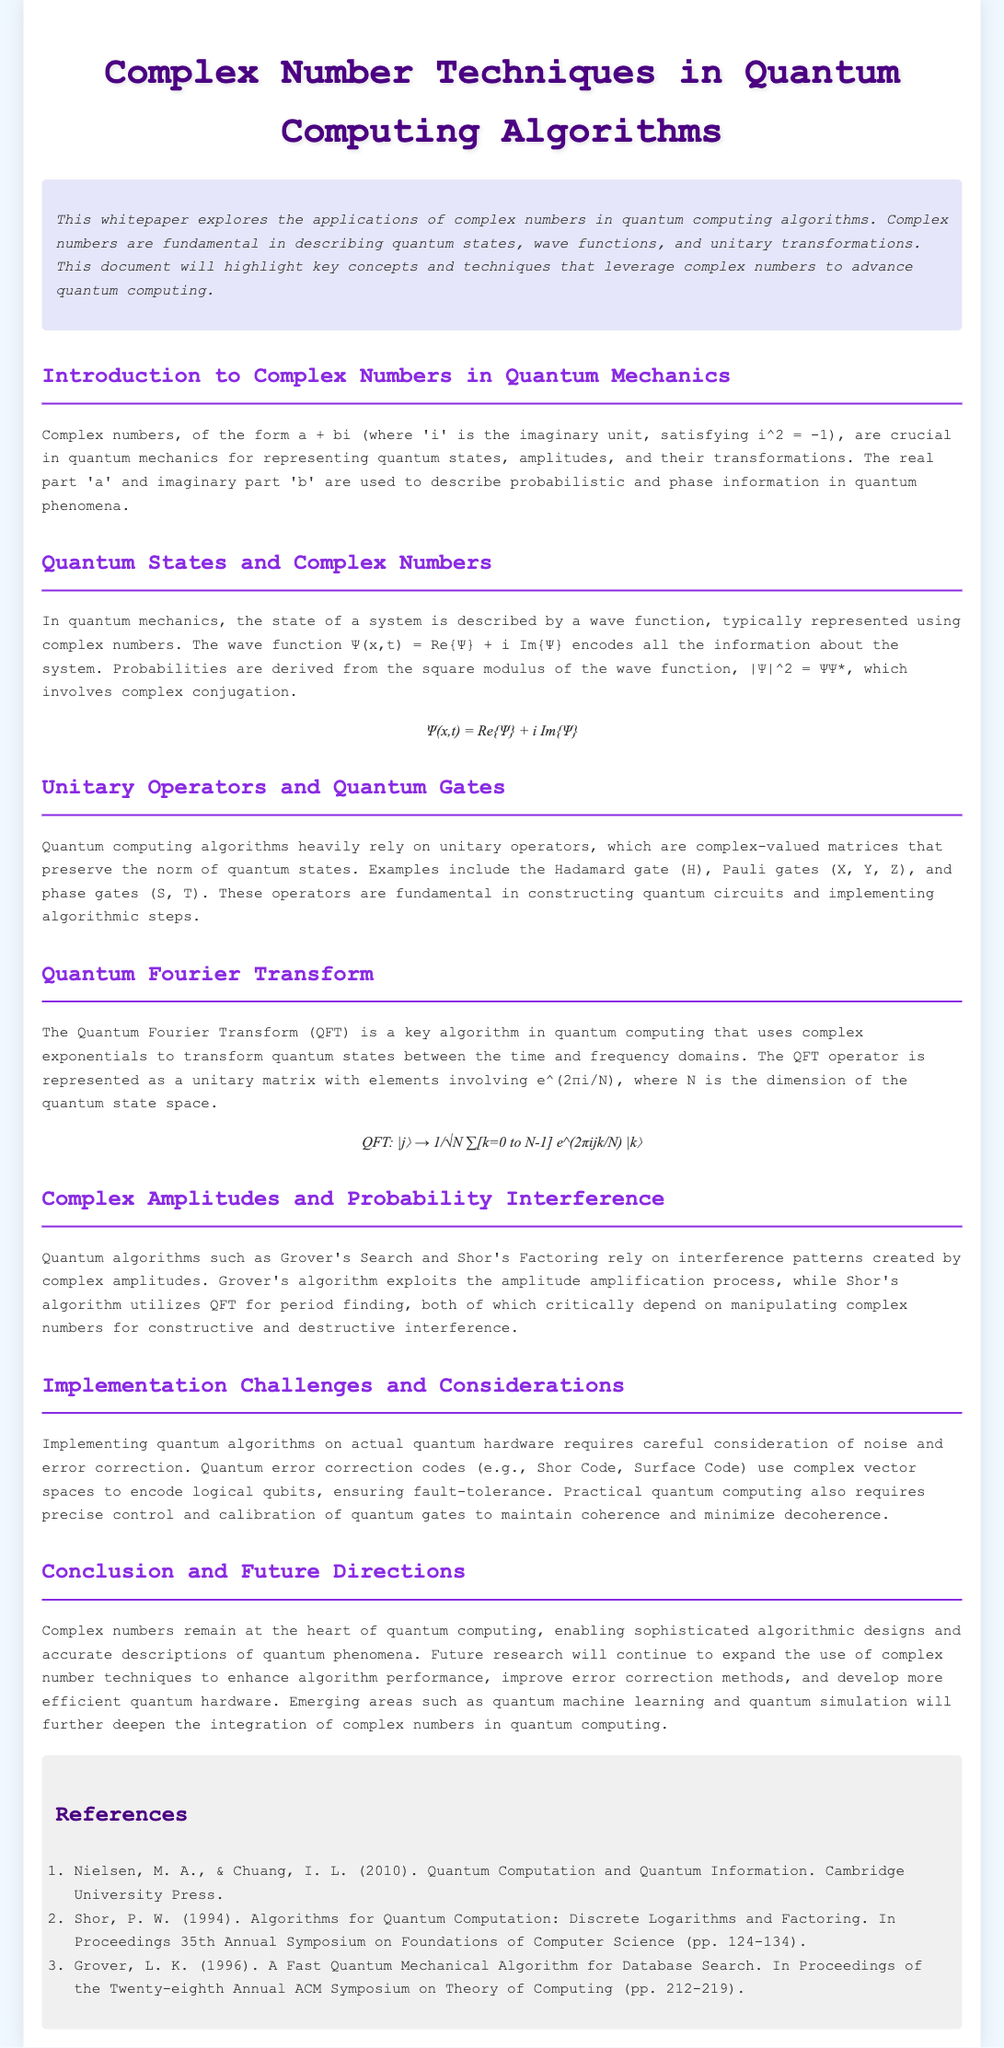What is the title of the whitepaper? The title is prominently displayed at the top of the document, indicating the focus of the research.
Answer: Complex Number Techniques in Quantum Computing Algorithms What are the two parts of a complex number? The definition of a complex number in the introduction specifies its components clearly.
Answer: Real part and imaginary part What type of operators are used in quantum computing algorithms? The section on Unitary Operators introduces the concept of these operators used within quantum circuits.
Answer: Unitary operators Which algorithm uses complex exponentials for transformation? The section on Quantum Fourier Transform describes the function of this algorithm in quantum computing.
Answer: Quantum Fourier Transform What does the square modulus of the wave function represent? This is discussed in the Quantum States section, providing insight into quantum state probabilities.
Answer: Probabilities Which gate is an example of a quantum gate? The Unitary Operators section enumerates various quantum gates, including the one requested.
Answer: Hadamard gate What is a key challenge in implementing quantum algorithms? The implementation challenges section highlights specific difficulties faced in real-world quantum computing.
Answer: Noise What future area is mentioned for deepening integration of complex numbers? The conclusion points towards emerging fields that will expand the use of complex numbers in quantum computing.
Answer: Quantum machine learning 